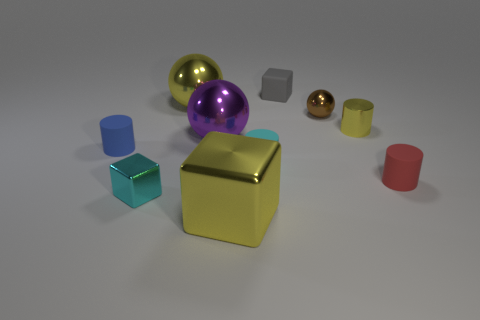Are there fewer small gray matte blocks to the left of the blue rubber thing than large purple objects?
Offer a very short reply. Yes. Is the shape of the blue object the same as the gray matte thing?
Offer a very short reply. No. Is there any other thing that has the same shape as the large purple object?
Make the answer very short. Yes. Are any small gray blocks visible?
Your answer should be very brief. Yes. Does the tiny blue rubber object have the same shape as the large yellow object in front of the cyan rubber cylinder?
Give a very brief answer. No. What is the material of the tiny cube right of the tiny block in front of the red thing?
Offer a very short reply. Rubber. What color is the big shiny cube?
Make the answer very short. Yellow. Is the color of the small matte cylinder to the right of the cyan rubber thing the same as the small block on the left side of the yellow ball?
Provide a succinct answer. No. There is a yellow metal object that is the same shape as the large purple shiny object; what size is it?
Keep it short and to the point. Large. Is there a large shiny ball of the same color as the tiny rubber block?
Ensure brevity in your answer.  No. 